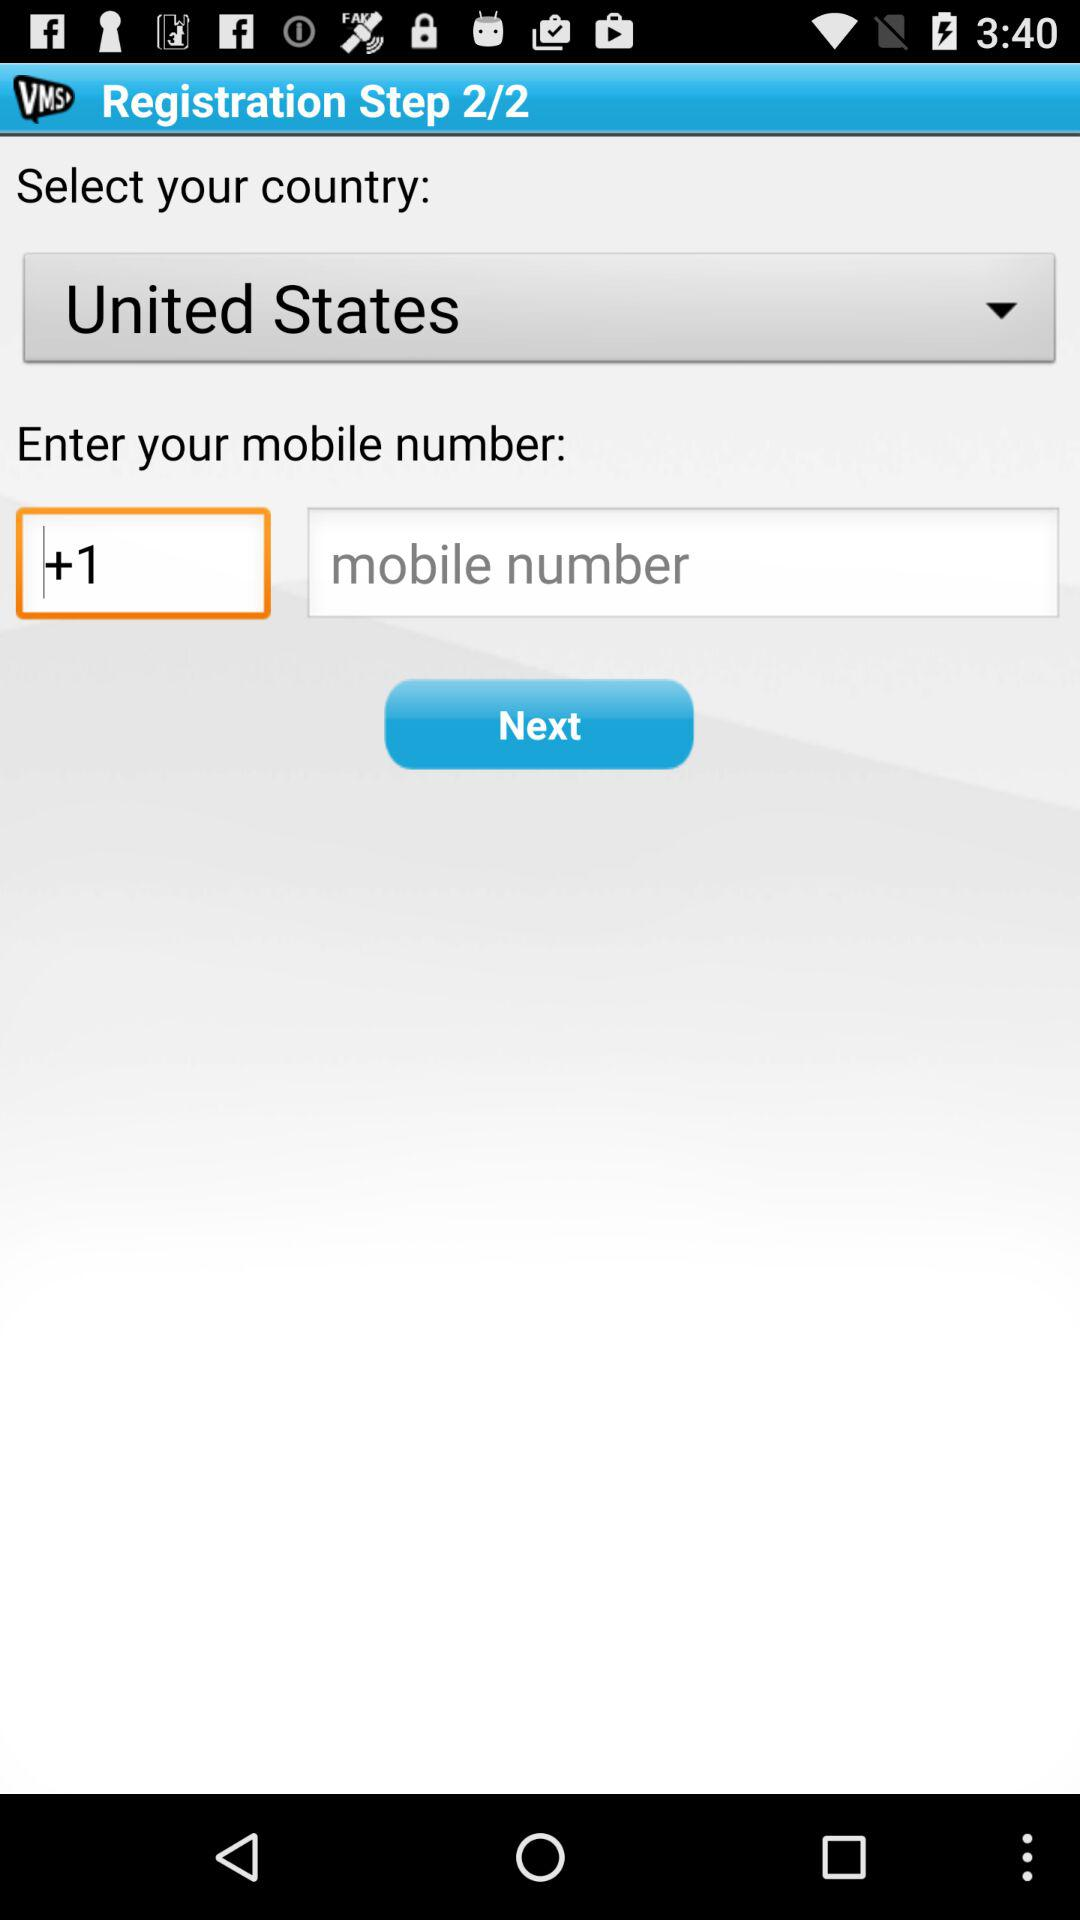Which countries are on the drop-down menu list?
When the provided information is insufficient, respond with <no answer>. <no answer> 